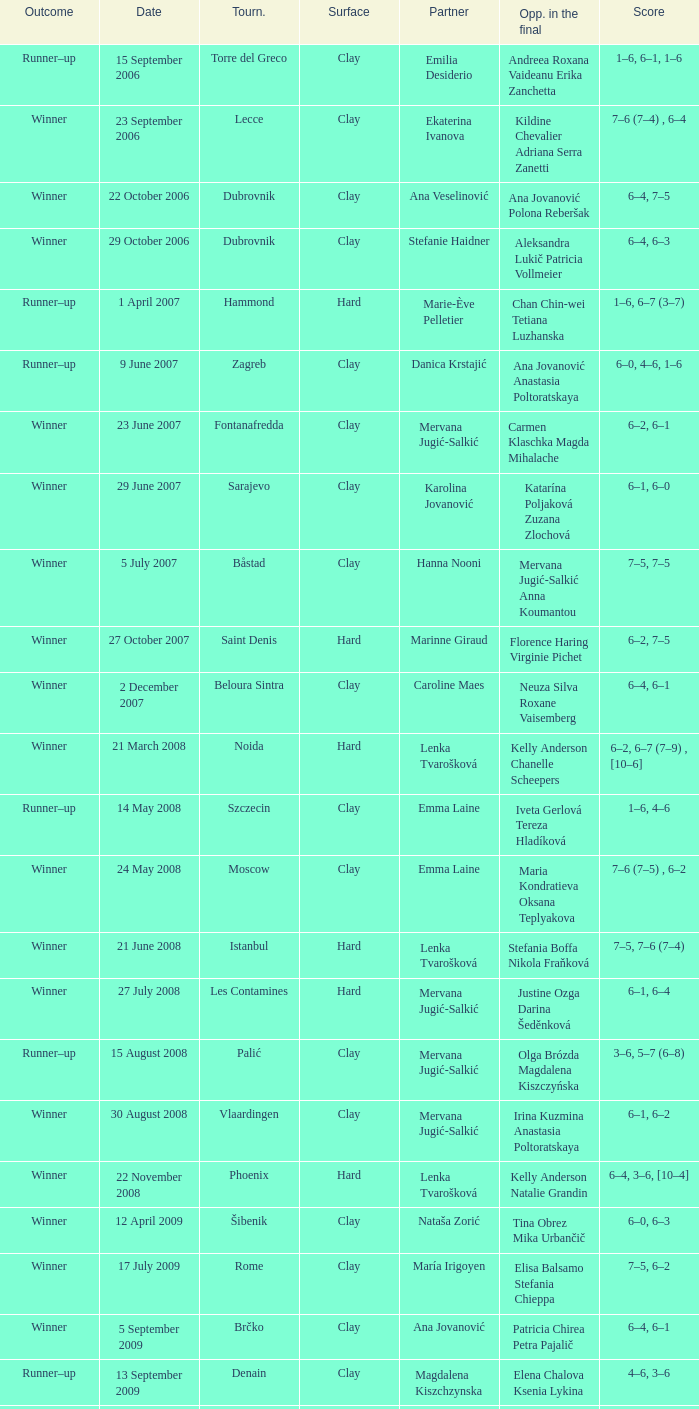Which tournament had a partner of Erika Sema? Aschaffenburg. 